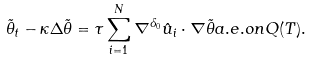Convert formula to latex. <formula><loc_0><loc_0><loc_500><loc_500>\tilde { \theta } _ { t } - \kappa \Delta \tilde { \theta } = \tau \sum _ { i = 1 } ^ { N } \nabla ^ { \delta _ { 0 } } \hat { u } _ { i } \cdot \nabla \tilde { \theta } a . e . o n Q ( T ) .</formula> 